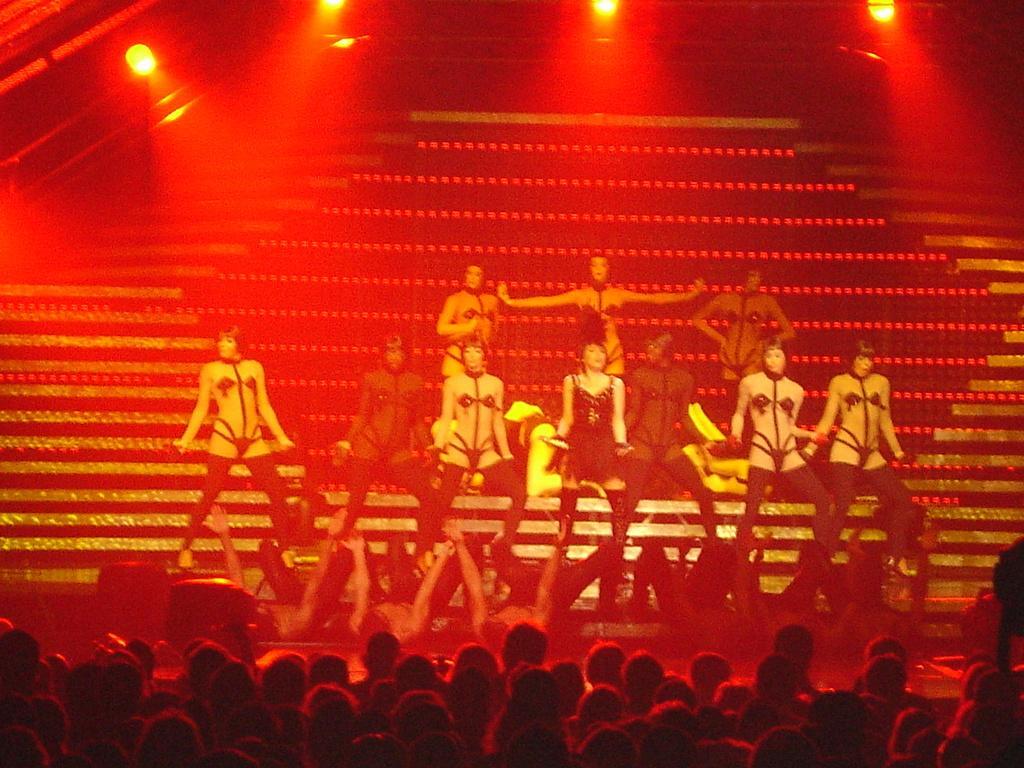In one or two sentences, can you explain what this image depicts? These people are dancing and these are audience. In the background we can see steps and lights. 